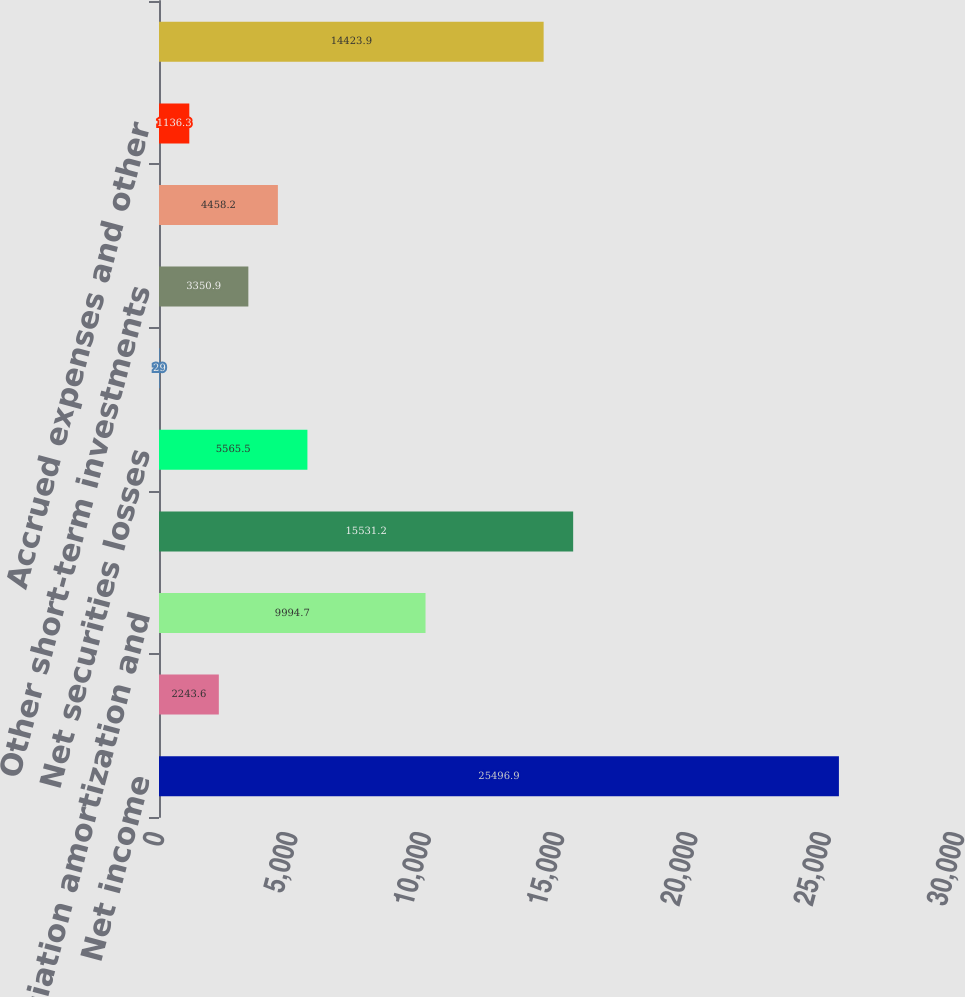<chart> <loc_0><loc_0><loc_500><loc_500><bar_chart><fcel>Net income<fcel>Provision for credit losses<fcel>Depreciation amortization and<fcel>Deferred income taxes<fcel>Net securities losses<fcel>Excess tax benefits from<fcel>Other short-term investments<fcel>Other assets<fcel>Accrued expenses and other<fcel>Other<nl><fcel>25496.9<fcel>2243.6<fcel>9994.7<fcel>15531.2<fcel>5565.5<fcel>29<fcel>3350.9<fcel>4458.2<fcel>1136.3<fcel>14423.9<nl></chart> 